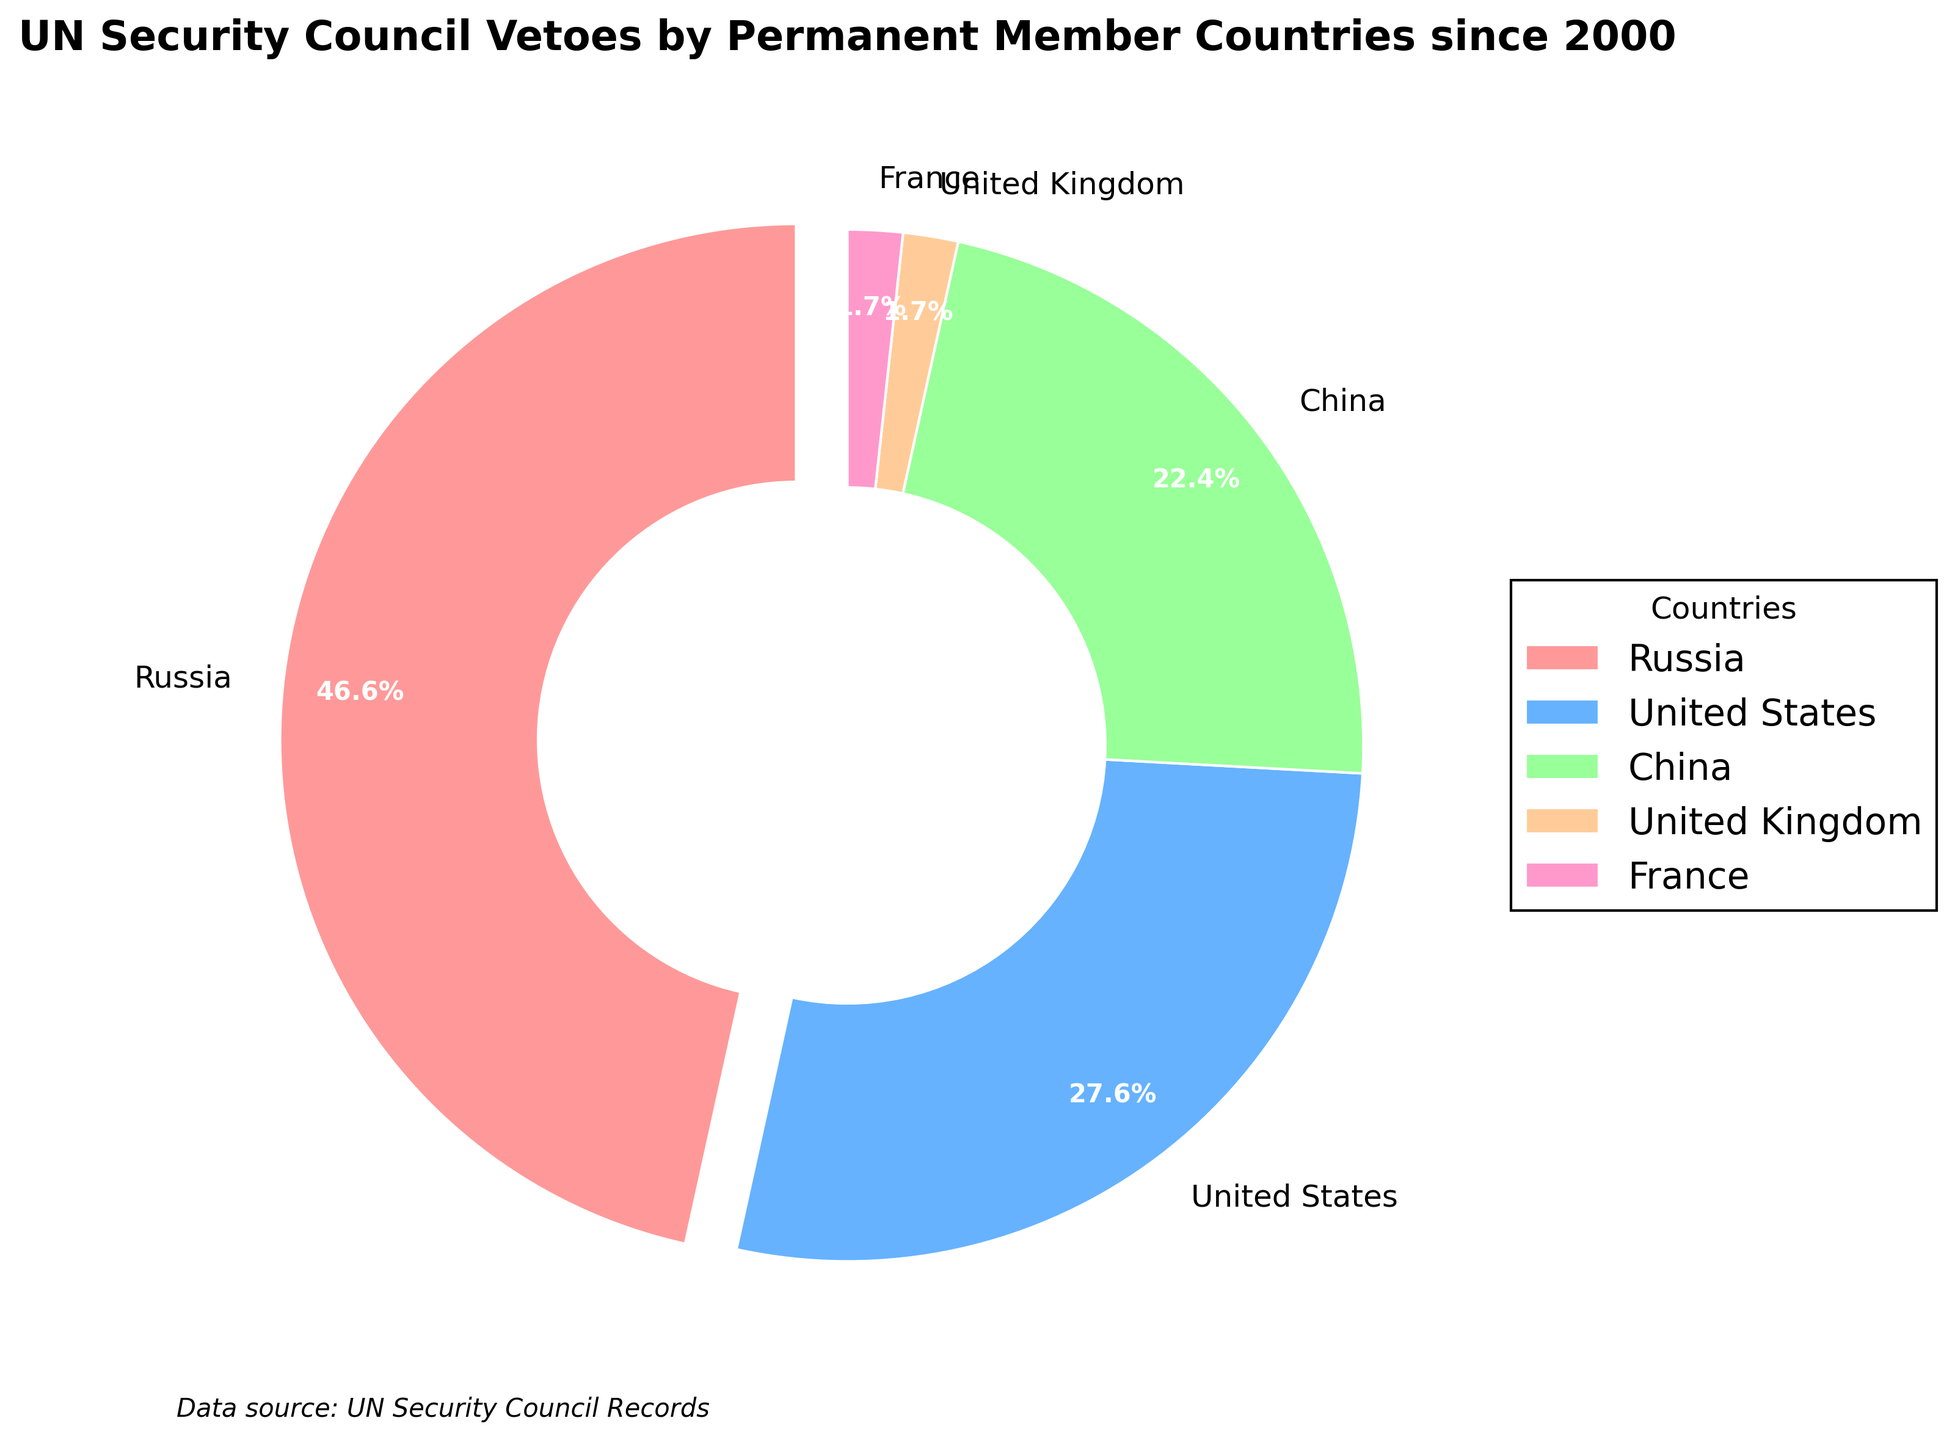How many total vetoes have been cast by all the permanent member countries since 2000? Sum the individual vetoes cast by each country: Russia (27) + United States (16) + China (13) + United Kingdom (1) + France (1). The total is 27 + 16 + 13 + 1 + 1 = 58
Answer: 58 Which country has cast the most vetoes since 2000? By looking at the pie chart, it is clear that Russia has the largest slice, indicating the highest number of vetoes.
Answer: Russia How many more vetoes have been cast by Russia compared to the United States? Subtract the number of vetoes cast by the United States from those cast by Russia: 27 - 16 = 11
Answer: 11 Is the number of vetoes cast by France equal to that by the United Kingdom? Both France and the United Kingdom have the smallest slices in the pie chart, each representing 1 veto. Therefore, they are equal.
Answer: Yes What proportion of the total number of vetoes since 2000 were cast by China? To find the proportion, divide the number of vetoes cast by China by the total number of vetoes: 13 / 58 ≈ 0.2241. Convert it to percentage form: 0.2241 * 100 ≈ 22.4%
Answer: 22.4% Which country has the smallest slice in the pie chart, and what are those countries? By inspecting the visual sizes of the slices, the smallest ones belong to both the United Kingdom and France.
Answer: United Kingdom and France By how much does the number of vetoes cast by China exceed that of the United Kingdom and France combined? Add the number of vetoes cast by the United Kingdom and France: 1 + 1 = 2. Then, subtract this sum from the number cast by China: 13 - 2 = 11
Answer: 11 Are there any countries whose pie chart segments are exploded (slightly separated from the center)? Yes, the segment representing Russia is slightly separated from the center of the pie chart, which emphasizes its prominence.
Answer: Yes What percentage of the vetoes were not cast by Russia? Subtract the proportion of vetoes cast by Russia from 100%: 100% - 46.6% (which is 27/58 * 100) ≈ 53.4%
Answer: 53.4% Which country’s segment is highlighted with a slight explosion, possibly indicating a special focus? The segment representing Russia is highlighted with a slight explosion from the rest of the pie chart, indicating a special focus.
Answer: Russia 